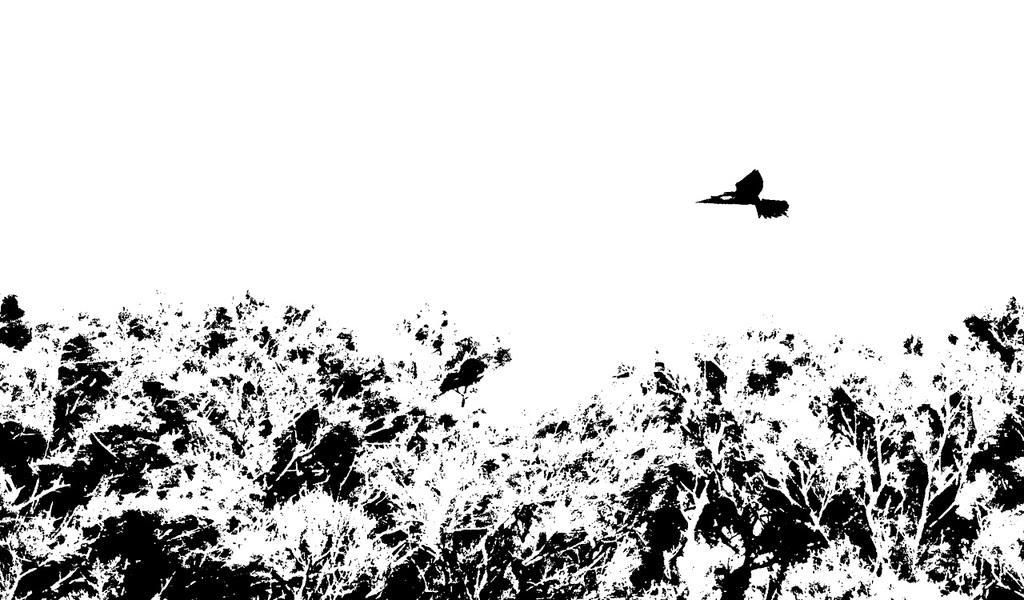Can you describe this image briefly? This might be an edited image in this image, at the bottom there are some trees and in the center there is one bird flying. 